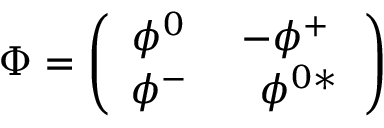Convert formula to latex. <formula><loc_0><loc_0><loc_500><loc_500>\Phi = \left ( \begin{array} { c c } { { \phi ^ { 0 } \ } } & { { - \phi ^ { + } \ } } \\ { { \phi ^ { - } \ } } & { { \ \phi ^ { 0 * } } } \end{array} \right )</formula> 